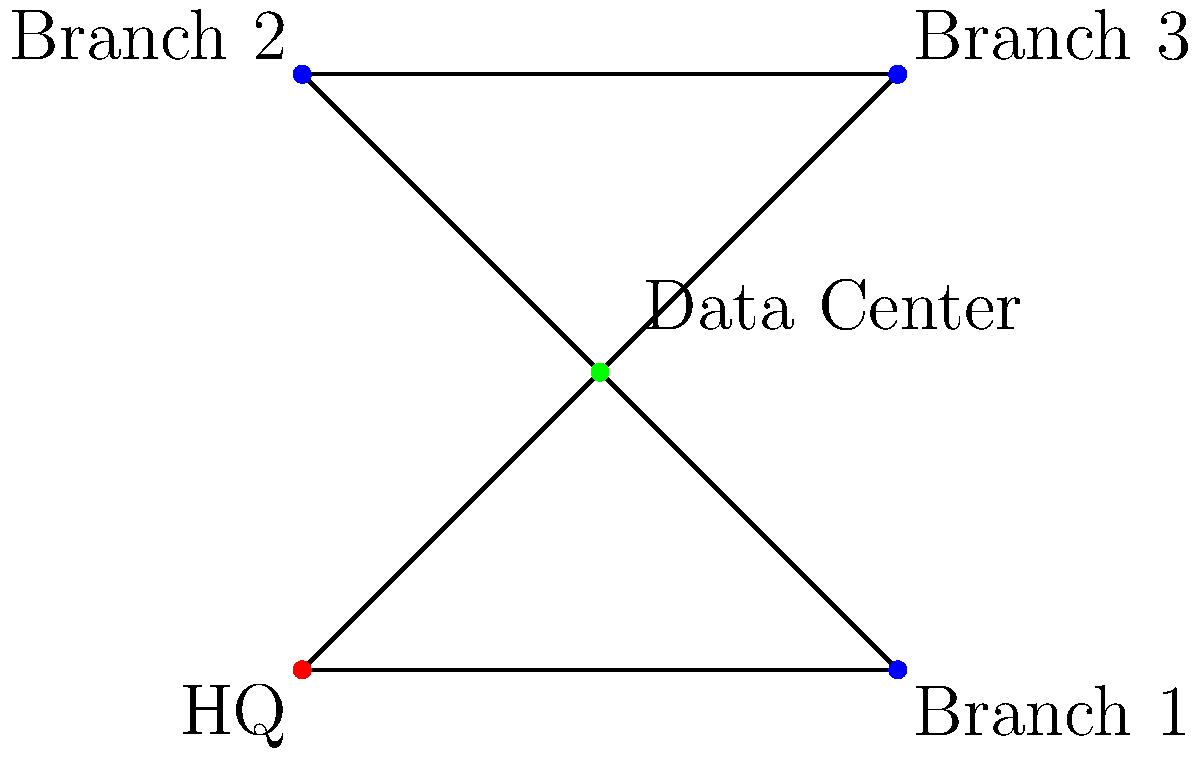As an executive overseeing network optimization, you're presented with the current network topology of your company. The headquarters (HQ) is connected to three branch offices and a central data center. To improve business communication and reduce latency, which node should be prioritized for upgrading its connection to achieve the most significant impact on overall network performance? To determine the optimal node for upgrading, we need to analyze the network topology and consider the following factors:

1. Centrality: Nodes with higher centrality have more connections and influence on the network.
2. Data flow: Consider the volume and importance of data passing through each node.
3. Bottleneck potential: Identify nodes that could become bottlenecks if not optimized.

Step-by-step analysis:

1. HQ (Node A):
   - Connected to Data Center and Branch 1
   - Important for overall business operations
   - Upgrading may improve communication with branches

2. Branch offices (Nodes B, D, E):
   - Connected to Data Center and HQ/other branches
   - Upgrading individual branches may not significantly impact overall network performance

3. Data Center (Node C):
   - Connected to all other nodes (highest centrality)
   - Likely handles the most data traffic
   - Acts as a central hub for all communication
   - Potential bottleneck if not optimized

Considering these factors, upgrading the Data Center's connection would have the most significant impact on overall network performance:

1. It would improve communication speed and reliability for all connected nodes.
2. Reduce latency for data transfers between branches and HQ.
3. Enhance the capacity to handle increased data flow as the business grows.
4. Mitigate the risk of the Data Center becoming a bottleneck in the network.

Therefore, prioritizing the upgrade of the Data Center's connection would yield the most substantial improvement in business communication and overall network performance.
Answer: Data Center 